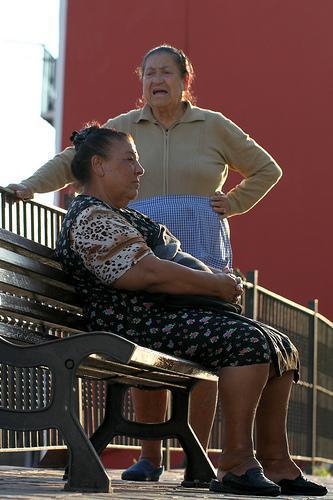How many women are shown?
Give a very brief answer. 2. How many benches are shown?
Give a very brief answer. 1. How many women are sitting on a bench?
Give a very brief answer. 1. 